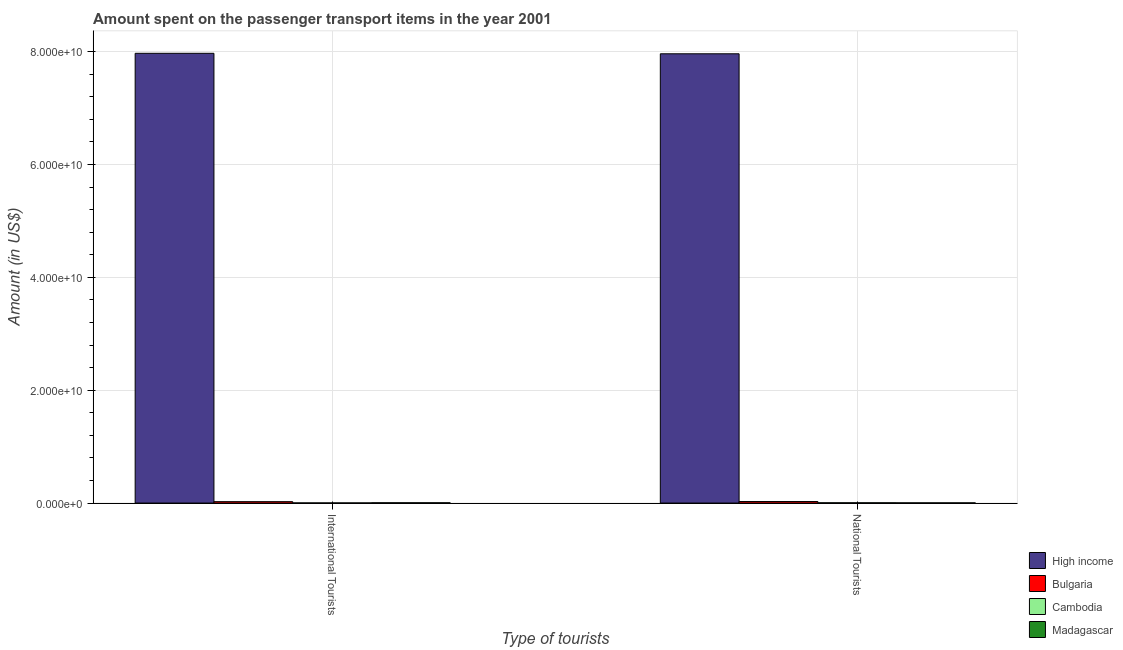How many bars are there on the 2nd tick from the left?
Give a very brief answer. 4. How many bars are there on the 1st tick from the right?
Your answer should be very brief. 4. What is the label of the 1st group of bars from the left?
Provide a short and direct response. International Tourists. What is the amount spent on transport items of national tourists in Cambodia?
Make the answer very short. 4.90e+07. Across all countries, what is the maximum amount spent on transport items of international tourists?
Provide a succinct answer. 7.97e+1. Across all countries, what is the minimum amount spent on transport items of national tourists?
Ensure brevity in your answer.  3.40e+07. In which country was the amount spent on transport items of national tourists maximum?
Provide a short and direct response. High income. In which country was the amount spent on transport items of international tourists minimum?
Your response must be concise. Cambodia. What is the total amount spent on transport items of international tourists in the graph?
Your response must be concise. 8.00e+1. What is the difference between the amount spent on transport items of international tourists in High income and that in Bulgaria?
Ensure brevity in your answer.  7.95e+1. What is the difference between the amount spent on transport items of international tourists in Cambodia and the amount spent on transport items of national tourists in Madagascar?
Your answer should be compact. -1.20e+07. What is the average amount spent on transport items of international tourists per country?
Make the answer very short. 2.00e+1. What is the difference between the amount spent on transport items of national tourists and amount spent on transport items of international tourists in Cambodia?
Make the answer very short. 2.70e+07. What is the ratio of the amount spent on transport items of international tourists in Cambodia to that in Bulgaria?
Your answer should be very brief. 0.09. In how many countries, is the amount spent on transport items of national tourists greater than the average amount spent on transport items of national tourists taken over all countries?
Ensure brevity in your answer.  1. What does the 4th bar from the left in National Tourists represents?
Offer a very short reply. Madagascar. Are all the bars in the graph horizontal?
Provide a short and direct response. No. What is the difference between two consecutive major ticks on the Y-axis?
Offer a terse response. 2.00e+1. Are the values on the major ticks of Y-axis written in scientific E-notation?
Keep it short and to the point. Yes. Does the graph contain any zero values?
Keep it short and to the point. No. Does the graph contain grids?
Make the answer very short. Yes. Where does the legend appear in the graph?
Give a very brief answer. Bottom right. How many legend labels are there?
Ensure brevity in your answer.  4. How are the legend labels stacked?
Keep it short and to the point. Vertical. What is the title of the graph?
Your answer should be compact. Amount spent on the passenger transport items in the year 2001. What is the label or title of the X-axis?
Your answer should be very brief. Type of tourists. What is the Amount (in US$) of High income in International Tourists?
Offer a terse response. 7.97e+1. What is the Amount (in US$) of Bulgaria in International Tourists?
Provide a short and direct response. 2.47e+08. What is the Amount (in US$) in Cambodia in International Tourists?
Offer a terse response. 2.20e+07. What is the Amount (in US$) in Madagascar in International Tourists?
Provide a short and direct response. 4.90e+07. What is the Amount (in US$) of High income in National Tourists?
Give a very brief answer. 7.96e+1. What is the Amount (in US$) in Bulgaria in National Tourists?
Give a very brief answer. 2.68e+08. What is the Amount (in US$) in Cambodia in National Tourists?
Give a very brief answer. 4.90e+07. What is the Amount (in US$) of Madagascar in National Tourists?
Make the answer very short. 3.40e+07. Across all Type of tourists, what is the maximum Amount (in US$) in High income?
Provide a short and direct response. 7.97e+1. Across all Type of tourists, what is the maximum Amount (in US$) in Bulgaria?
Offer a terse response. 2.68e+08. Across all Type of tourists, what is the maximum Amount (in US$) in Cambodia?
Provide a succinct answer. 4.90e+07. Across all Type of tourists, what is the maximum Amount (in US$) in Madagascar?
Your answer should be very brief. 4.90e+07. Across all Type of tourists, what is the minimum Amount (in US$) of High income?
Your answer should be very brief. 7.96e+1. Across all Type of tourists, what is the minimum Amount (in US$) of Bulgaria?
Ensure brevity in your answer.  2.47e+08. Across all Type of tourists, what is the minimum Amount (in US$) of Cambodia?
Keep it short and to the point. 2.20e+07. Across all Type of tourists, what is the minimum Amount (in US$) of Madagascar?
Offer a very short reply. 3.40e+07. What is the total Amount (in US$) of High income in the graph?
Keep it short and to the point. 1.59e+11. What is the total Amount (in US$) in Bulgaria in the graph?
Offer a terse response. 5.15e+08. What is the total Amount (in US$) of Cambodia in the graph?
Keep it short and to the point. 7.10e+07. What is the total Amount (in US$) of Madagascar in the graph?
Your answer should be very brief. 8.30e+07. What is the difference between the Amount (in US$) of High income in International Tourists and that in National Tourists?
Provide a short and direct response. 8.38e+07. What is the difference between the Amount (in US$) of Bulgaria in International Tourists and that in National Tourists?
Make the answer very short. -2.10e+07. What is the difference between the Amount (in US$) of Cambodia in International Tourists and that in National Tourists?
Your answer should be compact. -2.70e+07. What is the difference between the Amount (in US$) of Madagascar in International Tourists and that in National Tourists?
Your response must be concise. 1.50e+07. What is the difference between the Amount (in US$) in High income in International Tourists and the Amount (in US$) in Bulgaria in National Tourists?
Ensure brevity in your answer.  7.94e+1. What is the difference between the Amount (in US$) of High income in International Tourists and the Amount (in US$) of Cambodia in National Tourists?
Your answer should be compact. 7.97e+1. What is the difference between the Amount (in US$) in High income in International Tourists and the Amount (in US$) in Madagascar in National Tourists?
Your answer should be very brief. 7.97e+1. What is the difference between the Amount (in US$) in Bulgaria in International Tourists and the Amount (in US$) in Cambodia in National Tourists?
Your response must be concise. 1.98e+08. What is the difference between the Amount (in US$) in Bulgaria in International Tourists and the Amount (in US$) in Madagascar in National Tourists?
Your answer should be compact. 2.13e+08. What is the difference between the Amount (in US$) of Cambodia in International Tourists and the Amount (in US$) of Madagascar in National Tourists?
Your answer should be compact. -1.20e+07. What is the average Amount (in US$) in High income per Type of tourists?
Your answer should be compact. 7.97e+1. What is the average Amount (in US$) of Bulgaria per Type of tourists?
Your answer should be compact. 2.58e+08. What is the average Amount (in US$) in Cambodia per Type of tourists?
Your response must be concise. 3.55e+07. What is the average Amount (in US$) in Madagascar per Type of tourists?
Offer a very short reply. 4.15e+07. What is the difference between the Amount (in US$) in High income and Amount (in US$) in Bulgaria in International Tourists?
Provide a short and direct response. 7.95e+1. What is the difference between the Amount (in US$) of High income and Amount (in US$) of Cambodia in International Tourists?
Ensure brevity in your answer.  7.97e+1. What is the difference between the Amount (in US$) in High income and Amount (in US$) in Madagascar in International Tourists?
Keep it short and to the point. 7.97e+1. What is the difference between the Amount (in US$) in Bulgaria and Amount (in US$) in Cambodia in International Tourists?
Give a very brief answer. 2.25e+08. What is the difference between the Amount (in US$) in Bulgaria and Amount (in US$) in Madagascar in International Tourists?
Your response must be concise. 1.98e+08. What is the difference between the Amount (in US$) in Cambodia and Amount (in US$) in Madagascar in International Tourists?
Provide a short and direct response. -2.70e+07. What is the difference between the Amount (in US$) of High income and Amount (in US$) of Bulgaria in National Tourists?
Provide a short and direct response. 7.94e+1. What is the difference between the Amount (in US$) of High income and Amount (in US$) of Cambodia in National Tourists?
Provide a short and direct response. 7.96e+1. What is the difference between the Amount (in US$) in High income and Amount (in US$) in Madagascar in National Tourists?
Keep it short and to the point. 7.96e+1. What is the difference between the Amount (in US$) in Bulgaria and Amount (in US$) in Cambodia in National Tourists?
Ensure brevity in your answer.  2.19e+08. What is the difference between the Amount (in US$) in Bulgaria and Amount (in US$) in Madagascar in National Tourists?
Your answer should be very brief. 2.34e+08. What is the difference between the Amount (in US$) in Cambodia and Amount (in US$) in Madagascar in National Tourists?
Give a very brief answer. 1.50e+07. What is the ratio of the Amount (in US$) of High income in International Tourists to that in National Tourists?
Your response must be concise. 1. What is the ratio of the Amount (in US$) of Bulgaria in International Tourists to that in National Tourists?
Ensure brevity in your answer.  0.92. What is the ratio of the Amount (in US$) in Cambodia in International Tourists to that in National Tourists?
Make the answer very short. 0.45. What is the ratio of the Amount (in US$) in Madagascar in International Tourists to that in National Tourists?
Your answer should be very brief. 1.44. What is the difference between the highest and the second highest Amount (in US$) in High income?
Your answer should be very brief. 8.38e+07. What is the difference between the highest and the second highest Amount (in US$) of Bulgaria?
Offer a very short reply. 2.10e+07. What is the difference between the highest and the second highest Amount (in US$) in Cambodia?
Ensure brevity in your answer.  2.70e+07. What is the difference between the highest and the second highest Amount (in US$) in Madagascar?
Provide a succinct answer. 1.50e+07. What is the difference between the highest and the lowest Amount (in US$) of High income?
Keep it short and to the point. 8.38e+07. What is the difference between the highest and the lowest Amount (in US$) of Bulgaria?
Your answer should be very brief. 2.10e+07. What is the difference between the highest and the lowest Amount (in US$) of Cambodia?
Keep it short and to the point. 2.70e+07. What is the difference between the highest and the lowest Amount (in US$) of Madagascar?
Keep it short and to the point. 1.50e+07. 